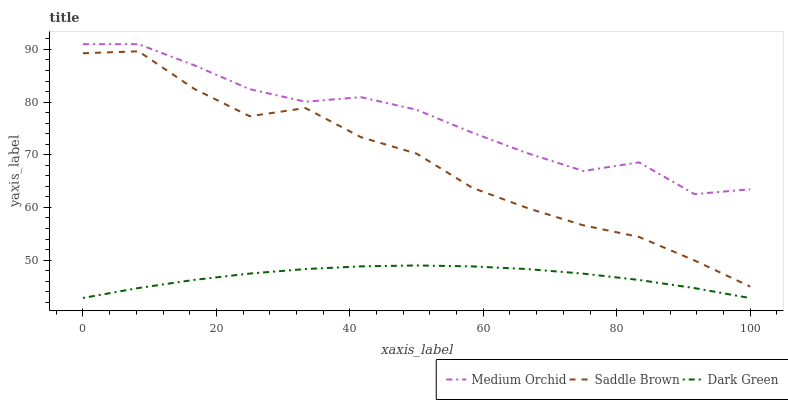Does Saddle Brown have the minimum area under the curve?
Answer yes or no. No. Does Saddle Brown have the maximum area under the curve?
Answer yes or no. No. Is Saddle Brown the smoothest?
Answer yes or no. No. Is Dark Green the roughest?
Answer yes or no. No. Does Saddle Brown have the lowest value?
Answer yes or no. No. Does Saddle Brown have the highest value?
Answer yes or no. No. Is Dark Green less than Medium Orchid?
Answer yes or no. Yes. Is Medium Orchid greater than Dark Green?
Answer yes or no. Yes. Does Dark Green intersect Medium Orchid?
Answer yes or no. No. 